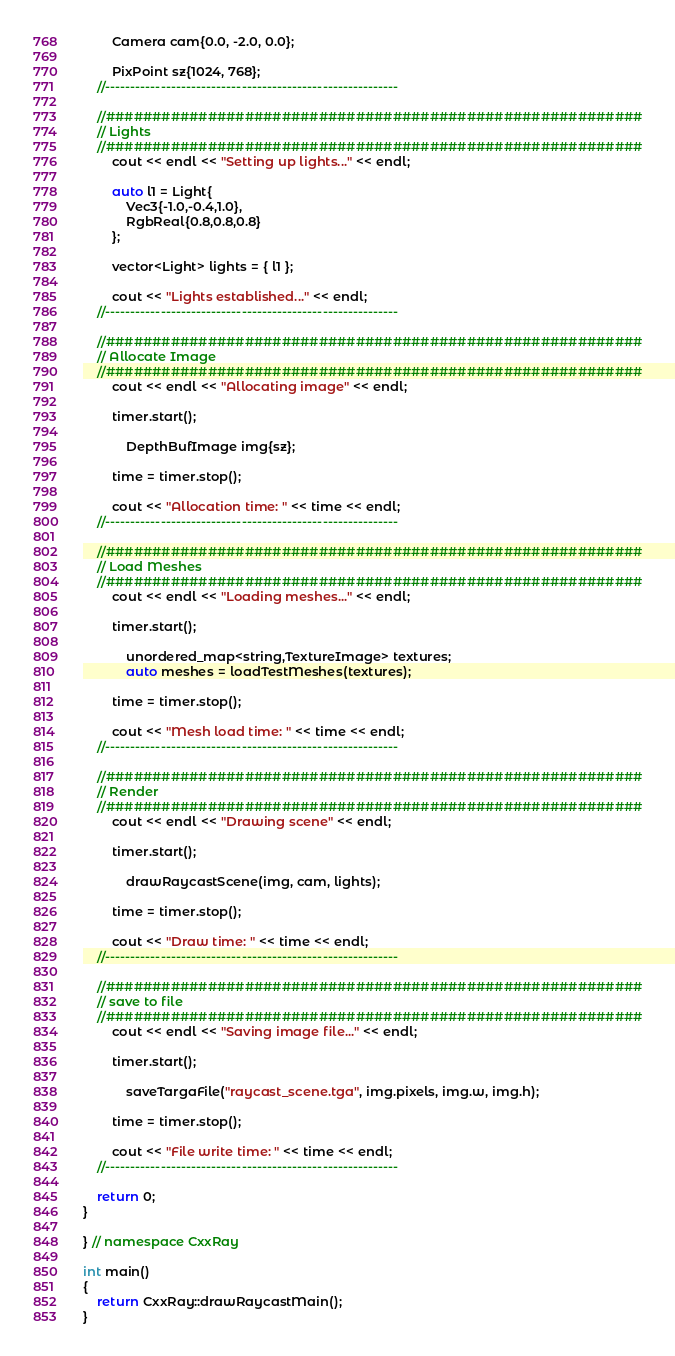Convert code to text. <code><loc_0><loc_0><loc_500><loc_500><_C++_>        Camera cam{0.0, -2.0, 0.0};

        PixPoint sz{1024, 768};
    //----------------------------------------------------------

    //##########################################################
    // Lights
    //##########################################################
        cout << endl << "Setting up lights..." << endl;

        auto l1 = Light{
            Vec3{-1.0,-0.4,1.0},
            RgbReal{0.8,0.8,0.8}
        };

        vector<Light> lights = { l1 };

        cout << "Lights established..." << endl;
    //----------------------------------------------------------

    //##########################################################
    // Allocate Image
    //##########################################################
        cout << endl << "Allocating image" << endl;

        timer.start();

            DepthBufImage img{sz};

        time = timer.stop();

        cout << "Allocation time: " << time << endl;
    //----------------------------------------------------------

    //##########################################################
    // Load Meshes
    //##########################################################
        cout << endl << "Loading meshes..." << endl;

        timer.start();

            unordered_map<string,TextureImage> textures;
            auto meshes = loadTestMeshes(textures);

        time = timer.stop();

        cout << "Mesh load time: " << time << endl;
    //----------------------------------------------------------

    //##########################################################
    // Render
    //##########################################################
        cout << endl << "Drawing scene" << endl;

        timer.start();

            drawRaycastScene(img, cam, lights);

        time = timer.stop();

        cout << "Draw time: " << time << endl;
    //----------------------------------------------------------

    //##########################################################
    // save to file
    //##########################################################
        cout << endl << "Saving image file..." << endl;

        timer.start();

            saveTargaFile("raycast_scene.tga", img.pixels, img.w, img.h);

        time = timer.stop();

        cout << "File write time: " << time << endl;
    //----------------------------------------------------------

    return 0;
}

} // namespace CxxRay

int main()
{
    return CxxRay::drawRaycastMain();
}
</code> 